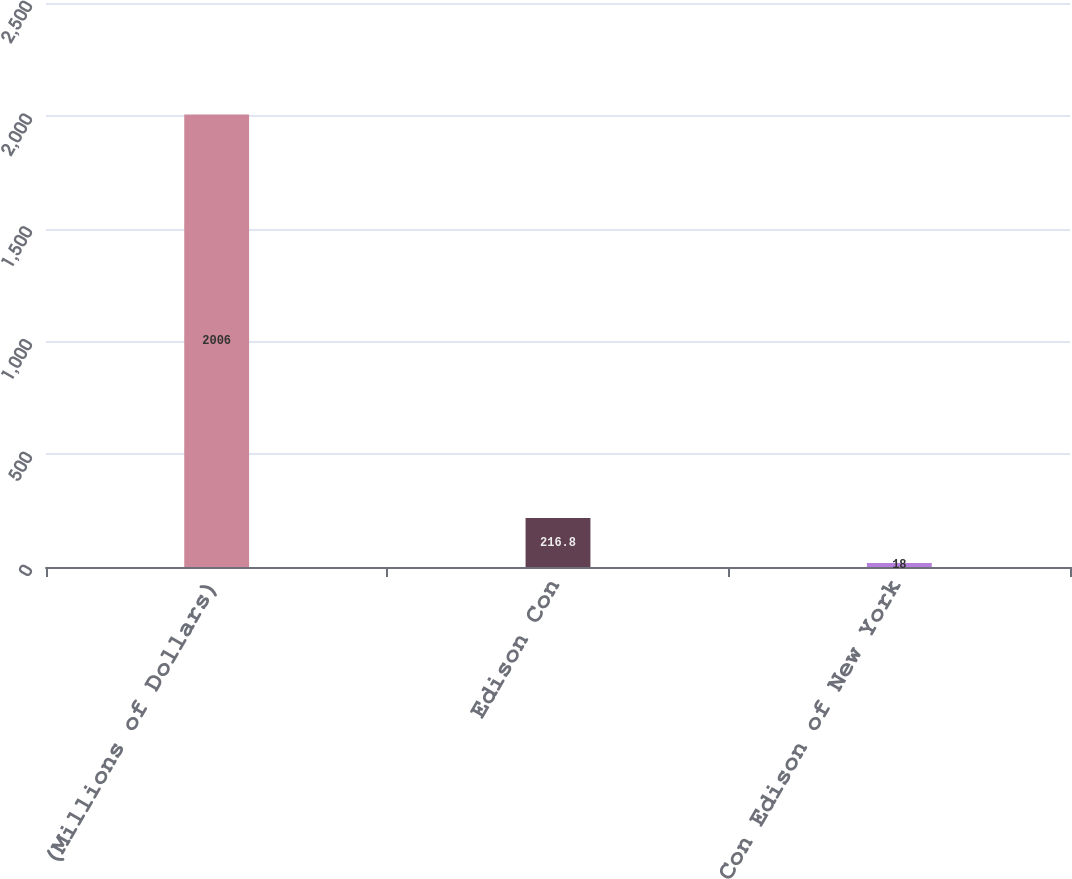Convert chart to OTSL. <chart><loc_0><loc_0><loc_500><loc_500><bar_chart><fcel>(Millions of Dollars)<fcel>Edison Con<fcel>Con Edison of New York<nl><fcel>2006<fcel>216.8<fcel>18<nl></chart> 